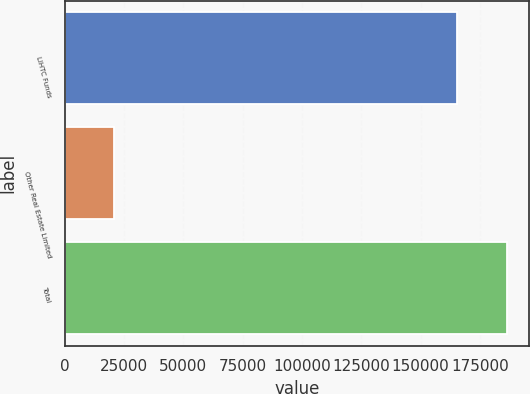Convert chart. <chart><loc_0><loc_0><loc_500><loc_500><bar_chart><fcel>LIHTC Funds<fcel>Other Real Estate Limited<fcel>Total<nl><fcel>165411<fcel>20994<fcel>186405<nl></chart> 